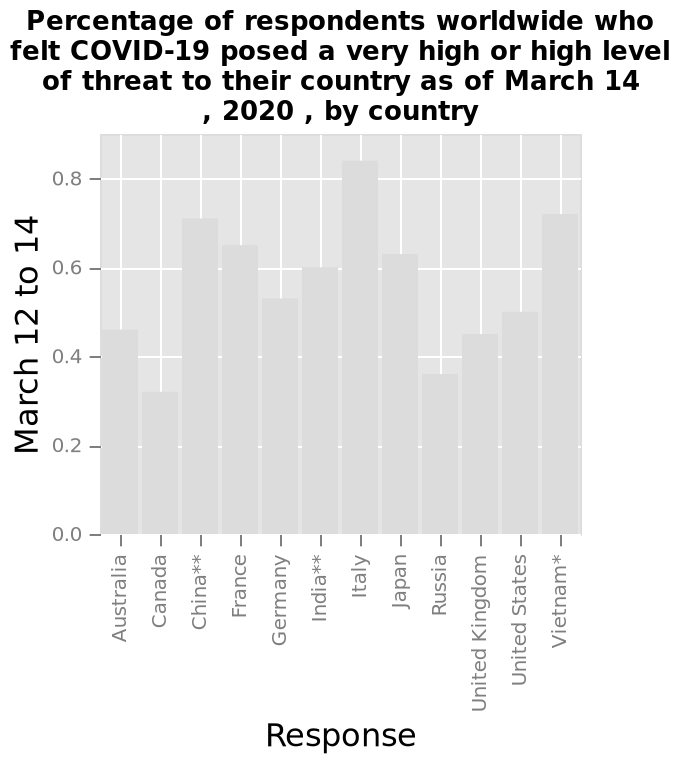<image>
What does the y-axis measure on the bar graph?  The y-axis measures the percentage of respondents worldwide who felt COVID-19 posed a very high or high level of threat to their country. What does the bar graph show?  The bar graph shows the percentage of respondents worldwide who felt COVID-19 posed a very high or high level of threat to their country as of March 14, 2020, for different countries. What is the main observation from the figure? The main observation is that there is no skew among different continental regions, but there are noticeable increases in COVID severity in some European countries, with a broad range of risk assessment between nations. 